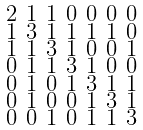Convert formula to latex. <formula><loc_0><loc_0><loc_500><loc_500>\begin{smallmatrix} 2 & 1 & 1 & 0 & 0 & 0 & 0 \\ 1 & 3 & 1 & 1 & 1 & 1 & 0 \\ 1 & 1 & 3 & 1 & 0 & 0 & 1 \\ 0 & 1 & 1 & 3 & 1 & 0 & 0 \\ 0 & 1 & 0 & 1 & 3 & 1 & 1 \\ 0 & 1 & 0 & 0 & 1 & 3 & 1 \\ 0 & 0 & 1 & 0 & 1 & 1 & 3 \end{smallmatrix}</formula> 